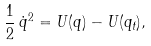<formula> <loc_0><loc_0><loc_500><loc_500>\frac { 1 } { 2 } \, { \dot { q } } ^ { 2 } = U ( q ) - U ( q _ { t } ) ,</formula> 